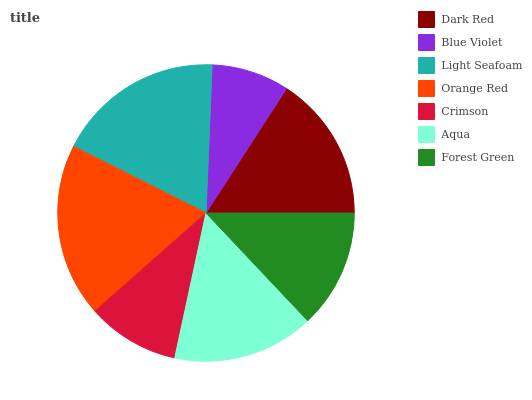Is Blue Violet the minimum?
Answer yes or no. Yes. Is Orange Red the maximum?
Answer yes or no. Yes. Is Light Seafoam the minimum?
Answer yes or no. No. Is Light Seafoam the maximum?
Answer yes or no. No. Is Light Seafoam greater than Blue Violet?
Answer yes or no. Yes. Is Blue Violet less than Light Seafoam?
Answer yes or no. Yes. Is Blue Violet greater than Light Seafoam?
Answer yes or no. No. Is Light Seafoam less than Blue Violet?
Answer yes or no. No. Is Aqua the high median?
Answer yes or no. Yes. Is Aqua the low median?
Answer yes or no. Yes. Is Orange Red the high median?
Answer yes or no. No. Is Orange Red the low median?
Answer yes or no. No. 